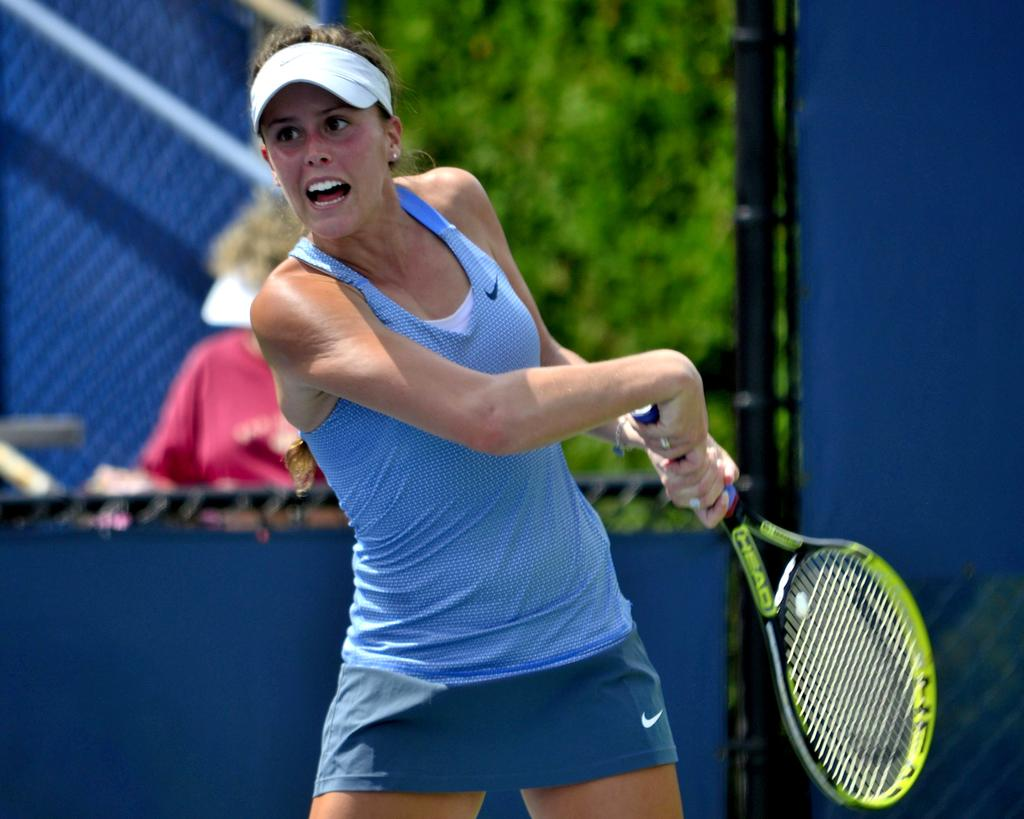How many people can be seen in the image? There are a few people in the image. What is one person doing in the image? One person is holding an object. What can be seen behind the people in the image? There is a background visible in the image, which includes trees. What color are some of the objects in the image? There are blue colored objects in the image. What type of fruit is growing on the root in the image? There is no fruit or root present in the image. Who is the expert in the image? There is no expert mentioned or depicted in the image. 